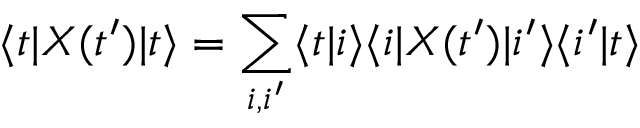Convert formula to latex. <formula><loc_0><loc_0><loc_500><loc_500>\langle t | X ( t ^ { \prime } ) | t \rangle = \sum _ { i , i ^ { \prime } } \langle t | i \rangle \langle i | X ( t ^ { \prime } ) | i ^ { \prime } \rangle \langle i ^ { \prime } | t \rangle</formula> 